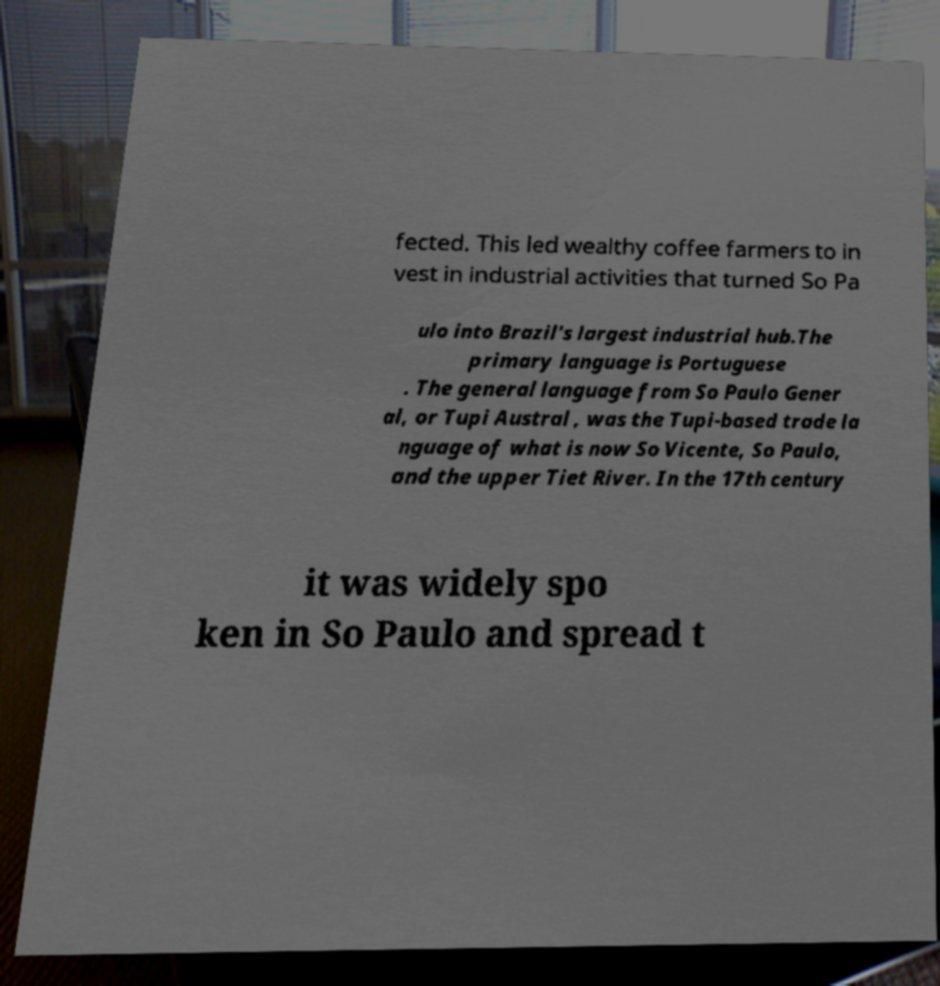For documentation purposes, I need the text within this image transcribed. Could you provide that? fected. This led wealthy coffee farmers to in vest in industrial activities that turned So Pa ulo into Brazil's largest industrial hub.The primary language is Portuguese . The general language from So Paulo Gener al, or Tupi Austral , was the Tupi-based trade la nguage of what is now So Vicente, So Paulo, and the upper Tiet River. In the 17th century it was widely spo ken in So Paulo and spread t 